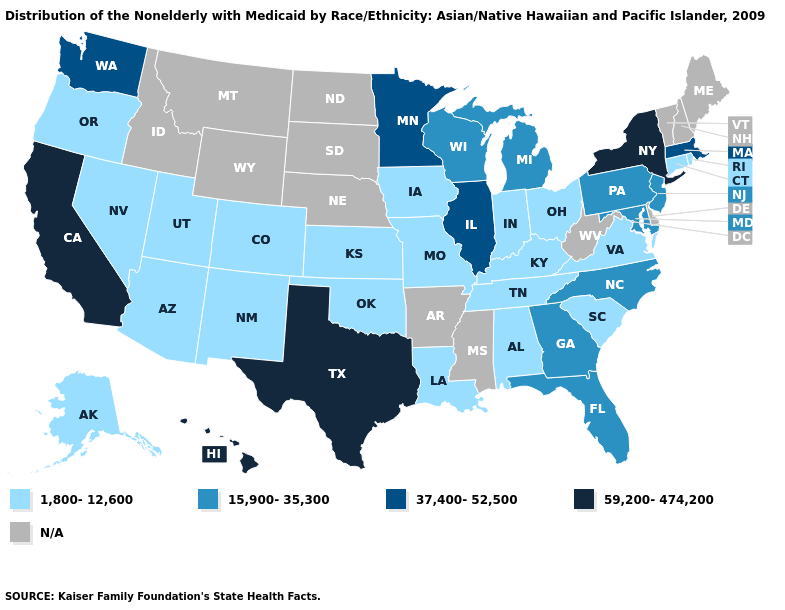Name the states that have a value in the range 37,400-52,500?
Write a very short answer. Illinois, Massachusetts, Minnesota, Washington. Is the legend a continuous bar?
Write a very short answer. No. What is the lowest value in states that border Florida?
Be succinct. 1,800-12,600. What is the value of New York?
Short answer required. 59,200-474,200. Which states have the highest value in the USA?
Short answer required. California, Hawaii, New York, Texas. What is the value of Wisconsin?
Keep it brief. 15,900-35,300. Name the states that have a value in the range 15,900-35,300?
Keep it brief. Florida, Georgia, Maryland, Michigan, New Jersey, North Carolina, Pennsylvania, Wisconsin. Which states hav the highest value in the West?
Keep it brief. California, Hawaii. What is the highest value in the West ?
Concise answer only. 59,200-474,200. Among the states that border Indiana , which have the highest value?
Keep it brief. Illinois. Which states have the highest value in the USA?
Keep it brief. California, Hawaii, New York, Texas. Name the states that have a value in the range N/A?
Give a very brief answer. Arkansas, Delaware, Idaho, Maine, Mississippi, Montana, Nebraska, New Hampshire, North Dakota, South Dakota, Vermont, West Virginia, Wyoming. What is the highest value in the USA?
Give a very brief answer. 59,200-474,200. Name the states that have a value in the range 1,800-12,600?
Be succinct. Alabama, Alaska, Arizona, Colorado, Connecticut, Indiana, Iowa, Kansas, Kentucky, Louisiana, Missouri, Nevada, New Mexico, Ohio, Oklahoma, Oregon, Rhode Island, South Carolina, Tennessee, Utah, Virginia. 